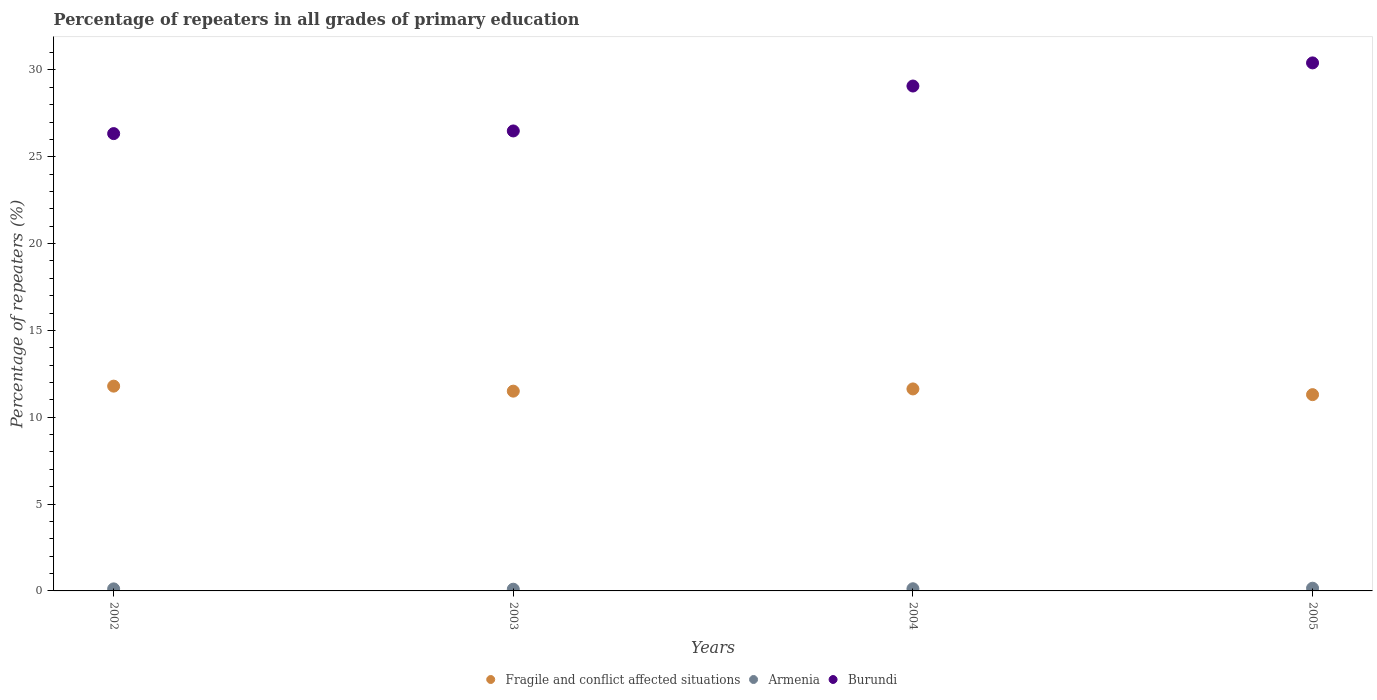Is the number of dotlines equal to the number of legend labels?
Make the answer very short. Yes. What is the percentage of repeaters in Burundi in 2003?
Give a very brief answer. 26.49. Across all years, what is the maximum percentage of repeaters in Armenia?
Keep it short and to the point. 0.16. Across all years, what is the minimum percentage of repeaters in Armenia?
Your response must be concise. 0.1. What is the total percentage of repeaters in Armenia in the graph?
Give a very brief answer. 0.5. What is the difference between the percentage of repeaters in Armenia in 2002 and that in 2003?
Provide a succinct answer. 0.02. What is the difference between the percentage of repeaters in Fragile and conflict affected situations in 2004 and the percentage of repeaters in Armenia in 2002?
Your answer should be very brief. 11.51. What is the average percentage of repeaters in Burundi per year?
Your answer should be very brief. 28.08. In the year 2005, what is the difference between the percentage of repeaters in Burundi and percentage of repeaters in Armenia?
Keep it short and to the point. 30.25. In how many years, is the percentage of repeaters in Armenia greater than 30 %?
Give a very brief answer. 0. What is the ratio of the percentage of repeaters in Burundi in 2002 to that in 2003?
Make the answer very short. 0.99. Is the percentage of repeaters in Armenia in 2004 less than that in 2005?
Provide a short and direct response. Yes. What is the difference between the highest and the second highest percentage of repeaters in Burundi?
Your answer should be compact. 1.33. What is the difference between the highest and the lowest percentage of repeaters in Armenia?
Your answer should be very brief. 0.06. Does the percentage of repeaters in Fragile and conflict affected situations monotonically increase over the years?
Your answer should be compact. No. Is the percentage of repeaters in Burundi strictly greater than the percentage of repeaters in Fragile and conflict affected situations over the years?
Your answer should be very brief. Yes. How many dotlines are there?
Offer a terse response. 3. How many years are there in the graph?
Your answer should be very brief. 4. Does the graph contain grids?
Your answer should be compact. No. How are the legend labels stacked?
Make the answer very short. Horizontal. What is the title of the graph?
Keep it short and to the point. Percentage of repeaters in all grades of primary education. Does "Gambia, The" appear as one of the legend labels in the graph?
Ensure brevity in your answer.  No. What is the label or title of the X-axis?
Your answer should be very brief. Years. What is the label or title of the Y-axis?
Provide a succinct answer. Percentage of repeaters (%). What is the Percentage of repeaters (%) in Fragile and conflict affected situations in 2002?
Provide a short and direct response. 11.79. What is the Percentage of repeaters (%) of Armenia in 2002?
Your answer should be very brief. 0.12. What is the Percentage of repeaters (%) of Burundi in 2002?
Ensure brevity in your answer.  26.33. What is the Percentage of repeaters (%) in Fragile and conflict affected situations in 2003?
Your answer should be very brief. 11.5. What is the Percentage of repeaters (%) in Armenia in 2003?
Your answer should be very brief. 0.1. What is the Percentage of repeaters (%) of Burundi in 2003?
Your answer should be very brief. 26.49. What is the Percentage of repeaters (%) of Fragile and conflict affected situations in 2004?
Provide a succinct answer. 11.63. What is the Percentage of repeaters (%) of Armenia in 2004?
Ensure brevity in your answer.  0.12. What is the Percentage of repeaters (%) in Burundi in 2004?
Make the answer very short. 29.07. What is the Percentage of repeaters (%) in Fragile and conflict affected situations in 2005?
Provide a succinct answer. 11.3. What is the Percentage of repeaters (%) in Armenia in 2005?
Your answer should be compact. 0.16. What is the Percentage of repeaters (%) of Burundi in 2005?
Offer a terse response. 30.41. Across all years, what is the maximum Percentage of repeaters (%) in Fragile and conflict affected situations?
Provide a short and direct response. 11.79. Across all years, what is the maximum Percentage of repeaters (%) in Armenia?
Your answer should be very brief. 0.16. Across all years, what is the maximum Percentage of repeaters (%) of Burundi?
Provide a short and direct response. 30.41. Across all years, what is the minimum Percentage of repeaters (%) of Fragile and conflict affected situations?
Offer a terse response. 11.3. Across all years, what is the minimum Percentage of repeaters (%) in Armenia?
Give a very brief answer. 0.1. Across all years, what is the minimum Percentage of repeaters (%) in Burundi?
Offer a very short reply. 26.33. What is the total Percentage of repeaters (%) of Fragile and conflict affected situations in the graph?
Your response must be concise. 46.23. What is the total Percentage of repeaters (%) in Armenia in the graph?
Ensure brevity in your answer.  0.5. What is the total Percentage of repeaters (%) of Burundi in the graph?
Offer a very short reply. 112.3. What is the difference between the Percentage of repeaters (%) in Fragile and conflict affected situations in 2002 and that in 2003?
Ensure brevity in your answer.  0.29. What is the difference between the Percentage of repeaters (%) of Armenia in 2002 and that in 2003?
Offer a terse response. 0.02. What is the difference between the Percentage of repeaters (%) of Burundi in 2002 and that in 2003?
Your response must be concise. -0.15. What is the difference between the Percentage of repeaters (%) of Fragile and conflict affected situations in 2002 and that in 2004?
Give a very brief answer. 0.16. What is the difference between the Percentage of repeaters (%) of Armenia in 2002 and that in 2004?
Your response must be concise. -0.01. What is the difference between the Percentage of repeaters (%) of Burundi in 2002 and that in 2004?
Offer a terse response. -2.74. What is the difference between the Percentage of repeaters (%) in Fragile and conflict affected situations in 2002 and that in 2005?
Keep it short and to the point. 0.49. What is the difference between the Percentage of repeaters (%) of Armenia in 2002 and that in 2005?
Offer a terse response. -0.04. What is the difference between the Percentage of repeaters (%) of Burundi in 2002 and that in 2005?
Give a very brief answer. -4.07. What is the difference between the Percentage of repeaters (%) of Fragile and conflict affected situations in 2003 and that in 2004?
Your answer should be very brief. -0.13. What is the difference between the Percentage of repeaters (%) in Armenia in 2003 and that in 2004?
Keep it short and to the point. -0.03. What is the difference between the Percentage of repeaters (%) in Burundi in 2003 and that in 2004?
Offer a terse response. -2.59. What is the difference between the Percentage of repeaters (%) of Fragile and conflict affected situations in 2003 and that in 2005?
Provide a short and direct response. 0.2. What is the difference between the Percentage of repeaters (%) in Armenia in 2003 and that in 2005?
Offer a terse response. -0.06. What is the difference between the Percentage of repeaters (%) of Burundi in 2003 and that in 2005?
Your answer should be very brief. -3.92. What is the difference between the Percentage of repeaters (%) in Fragile and conflict affected situations in 2004 and that in 2005?
Your answer should be compact. 0.33. What is the difference between the Percentage of repeaters (%) in Armenia in 2004 and that in 2005?
Your answer should be compact. -0.03. What is the difference between the Percentage of repeaters (%) in Burundi in 2004 and that in 2005?
Ensure brevity in your answer.  -1.33. What is the difference between the Percentage of repeaters (%) in Fragile and conflict affected situations in 2002 and the Percentage of repeaters (%) in Armenia in 2003?
Offer a terse response. 11.69. What is the difference between the Percentage of repeaters (%) of Fragile and conflict affected situations in 2002 and the Percentage of repeaters (%) of Burundi in 2003?
Provide a succinct answer. -14.69. What is the difference between the Percentage of repeaters (%) of Armenia in 2002 and the Percentage of repeaters (%) of Burundi in 2003?
Your answer should be very brief. -26.37. What is the difference between the Percentage of repeaters (%) of Fragile and conflict affected situations in 2002 and the Percentage of repeaters (%) of Armenia in 2004?
Give a very brief answer. 11.67. What is the difference between the Percentage of repeaters (%) of Fragile and conflict affected situations in 2002 and the Percentage of repeaters (%) of Burundi in 2004?
Give a very brief answer. -17.28. What is the difference between the Percentage of repeaters (%) of Armenia in 2002 and the Percentage of repeaters (%) of Burundi in 2004?
Ensure brevity in your answer.  -28.96. What is the difference between the Percentage of repeaters (%) of Fragile and conflict affected situations in 2002 and the Percentage of repeaters (%) of Armenia in 2005?
Your answer should be very brief. 11.64. What is the difference between the Percentage of repeaters (%) in Fragile and conflict affected situations in 2002 and the Percentage of repeaters (%) in Burundi in 2005?
Keep it short and to the point. -18.61. What is the difference between the Percentage of repeaters (%) in Armenia in 2002 and the Percentage of repeaters (%) in Burundi in 2005?
Your response must be concise. -30.29. What is the difference between the Percentage of repeaters (%) of Fragile and conflict affected situations in 2003 and the Percentage of repeaters (%) of Armenia in 2004?
Your response must be concise. 11.38. What is the difference between the Percentage of repeaters (%) in Fragile and conflict affected situations in 2003 and the Percentage of repeaters (%) in Burundi in 2004?
Ensure brevity in your answer.  -17.57. What is the difference between the Percentage of repeaters (%) in Armenia in 2003 and the Percentage of repeaters (%) in Burundi in 2004?
Keep it short and to the point. -28.98. What is the difference between the Percentage of repeaters (%) in Fragile and conflict affected situations in 2003 and the Percentage of repeaters (%) in Armenia in 2005?
Offer a terse response. 11.35. What is the difference between the Percentage of repeaters (%) of Fragile and conflict affected situations in 2003 and the Percentage of repeaters (%) of Burundi in 2005?
Ensure brevity in your answer.  -18.9. What is the difference between the Percentage of repeaters (%) of Armenia in 2003 and the Percentage of repeaters (%) of Burundi in 2005?
Offer a very short reply. -30.31. What is the difference between the Percentage of repeaters (%) in Fragile and conflict affected situations in 2004 and the Percentage of repeaters (%) in Armenia in 2005?
Your answer should be compact. 11.48. What is the difference between the Percentage of repeaters (%) in Fragile and conflict affected situations in 2004 and the Percentage of repeaters (%) in Burundi in 2005?
Provide a short and direct response. -18.77. What is the difference between the Percentage of repeaters (%) of Armenia in 2004 and the Percentage of repeaters (%) of Burundi in 2005?
Ensure brevity in your answer.  -30.28. What is the average Percentage of repeaters (%) of Fragile and conflict affected situations per year?
Provide a short and direct response. 11.56. What is the average Percentage of repeaters (%) in Armenia per year?
Your answer should be very brief. 0.12. What is the average Percentage of repeaters (%) of Burundi per year?
Offer a very short reply. 28.08. In the year 2002, what is the difference between the Percentage of repeaters (%) of Fragile and conflict affected situations and Percentage of repeaters (%) of Armenia?
Provide a succinct answer. 11.68. In the year 2002, what is the difference between the Percentage of repeaters (%) in Fragile and conflict affected situations and Percentage of repeaters (%) in Burundi?
Make the answer very short. -14.54. In the year 2002, what is the difference between the Percentage of repeaters (%) in Armenia and Percentage of repeaters (%) in Burundi?
Your answer should be very brief. -26.22. In the year 2003, what is the difference between the Percentage of repeaters (%) in Fragile and conflict affected situations and Percentage of repeaters (%) in Armenia?
Your answer should be compact. 11.41. In the year 2003, what is the difference between the Percentage of repeaters (%) of Fragile and conflict affected situations and Percentage of repeaters (%) of Burundi?
Offer a very short reply. -14.98. In the year 2003, what is the difference between the Percentage of repeaters (%) of Armenia and Percentage of repeaters (%) of Burundi?
Keep it short and to the point. -26.39. In the year 2004, what is the difference between the Percentage of repeaters (%) of Fragile and conflict affected situations and Percentage of repeaters (%) of Armenia?
Give a very brief answer. 11.51. In the year 2004, what is the difference between the Percentage of repeaters (%) of Fragile and conflict affected situations and Percentage of repeaters (%) of Burundi?
Ensure brevity in your answer.  -17.44. In the year 2004, what is the difference between the Percentage of repeaters (%) in Armenia and Percentage of repeaters (%) in Burundi?
Offer a terse response. -28.95. In the year 2005, what is the difference between the Percentage of repeaters (%) in Fragile and conflict affected situations and Percentage of repeaters (%) in Armenia?
Provide a succinct answer. 11.15. In the year 2005, what is the difference between the Percentage of repeaters (%) of Fragile and conflict affected situations and Percentage of repeaters (%) of Burundi?
Your response must be concise. -19.1. In the year 2005, what is the difference between the Percentage of repeaters (%) of Armenia and Percentage of repeaters (%) of Burundi?
Make the answer very short. -30.25. What is the ratio of the Percentage of repeaters (%) of Fragile and conflict affected situations in 2002 to that in 2003?
Provide a short and direct response. 1.03. What is the ratio of the Percentage of repeaters (%) of Armenia in 2002 to that in 2003?
Give a very brief answer. 1.19. What is the ratio of the Percentage of repeaters (%) of Burundi in 2002 to that in 2003?
Make the answer very short. 0.99. What is the ratio of the Percentage of repeaters (%) of Fragile and conflict affected situations in 2002 to that in 2004?
Offer a very short reply. 1.01. What is the ratio of the Percentage of repeaters (%) of Armenia in 2002 to that in 2004?
Provide a short and direct response. 0.94. What is the ratio of the Percentage of repeaters (%) in Burundi in 2002 to that in 2004?
Give a very brief answer. 0.91. What is the ratio of the Percentage of repeaters (%) in Fragile and conflict affected situations in 2002 to that in 2005?
Provide a short and direct response. 1.04. What is the ratio of the Percentage of repeaters (%) in Armenia in 2002 to that in 2005?
Offer a terse response. 0.76. What is the ratio of the Percentage of repeaters (%) of Burundi in 2002 to that in 2005?
Provide a short and direct response. 0.87. What is the ratio of the Percentage of repeaters (%) in Fragile and conflict affected situations in 2003 to that in 2004?
Give a very brief answer. 0.99. What is the ratio of the Percentage of repeaters (%) in Armenia in 2003 to that in 2004?
Offer a very short reply. 0.79. What is the ratio of the Percentage of repeaters (%) of Burundi in 2003 to that in 2004?
Provide a succinct answer. 0.91. What is the ratio of the Percentage of repeaters (%) in Fragile and conflict affected situations in 2003 to that in 2005?
Provide a short and direct response. 1.02. What is the ratio of the Percentage of repeaters (%) of Armenia in 2003 to that in 2005?
Make the answer very short. 0.63. What is the ratio of the Percentage of repeaters (%) in Burundi in 2003 to that in 2005?
Give a very brief answer. 0.87. What is the ratio of the Percentage of repeaters (%) in Fragile and conflict affected situations in 2004 to that in 2005?
Your response must be concise. 1.03. What is the ratio of the Percentage of repeaters (%) of Armenia in 2004 to that in 2005?
Offer a very short reply. 0.8. What is the ratio of the Percentage of repeaters (%) of Burundi in 2004 to that in 2005?
Ensure brevity in your answer.  0.96. What is the difference between the highest and the second highest Percentage of repeaters (%) in Fragile and conflict affected situations?
Ensure brevity in your answer.  0.16. What is the difference between the highest and the second highest Percentage of repeaters (%) of Armenia?
Keep it short and to the point. 0.03. What is the difference between the highest and the second highest Percentage of repeaters (%) of Burundi?
Provide a succinct answer. 1.33. What is the difference between the highest and the lowest Percentage of repeaters (%) in Fragile and conflict affected situations?
Ensure brevity in your answer.  0.49. What is the difference between the highest and the lowest Percentage of repeaters (%) of Armenia?
Give a very brief answer. 0.06. What is the difference between the highest and the lowest Percentage of repeaters (%) in Burundi?
Your answer should be compact. 4.07. 